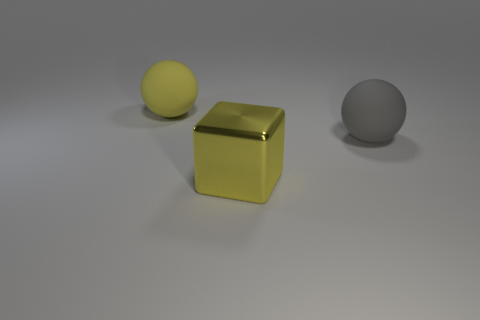Add 1 large rubber balls. How many objects exist? 4 Subtract all balls. How many objects are left? 1 Subtract all yellow things. Subtract all yellow matte spheres. How many objects are left? 0 Add 1 yellow metal things. How many yellow metal things are left? 2 Add 1 tiny blue shiny cylinders. How many tiny blue shiny cylinders exist? 1 Subtract 0 brown cubes. How many objects are left? 3 